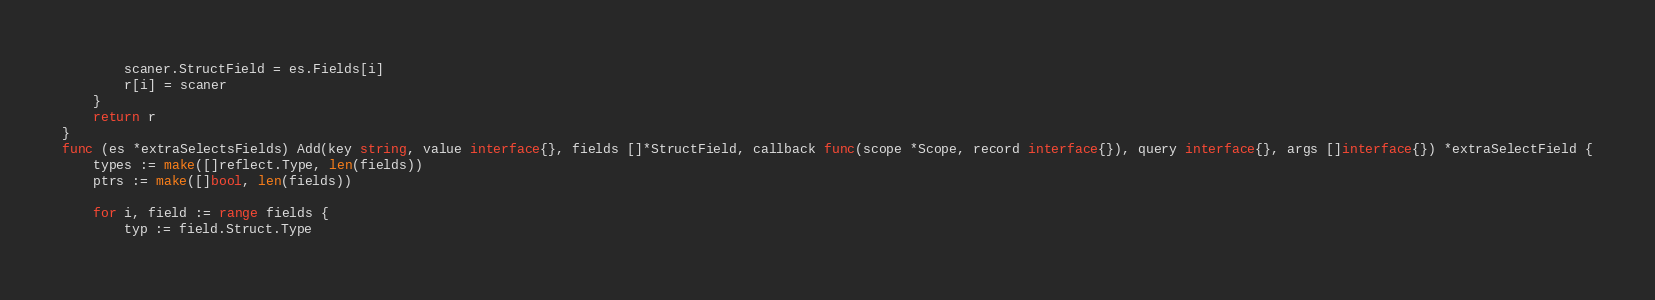Convert code to text. <code><loc_0><loc_0><loc_500><loc_500><_Go_>		scaner.StructField = es.Fields[i]
		r[i] = scaner
	}
	return r
}
func (es *extraSelectsFields) Add(key string, value interface{}, fields []*StructField, callback func(scope *Scope, record interface{}), query interface{}, args []interface{}) *extraSelectField {
	types := make([]reflect.Type, len(fields))
	ptrs := make([]bool, len(fields))

	for i, field := range fields {
		typ := field.Struct.Type</code> 